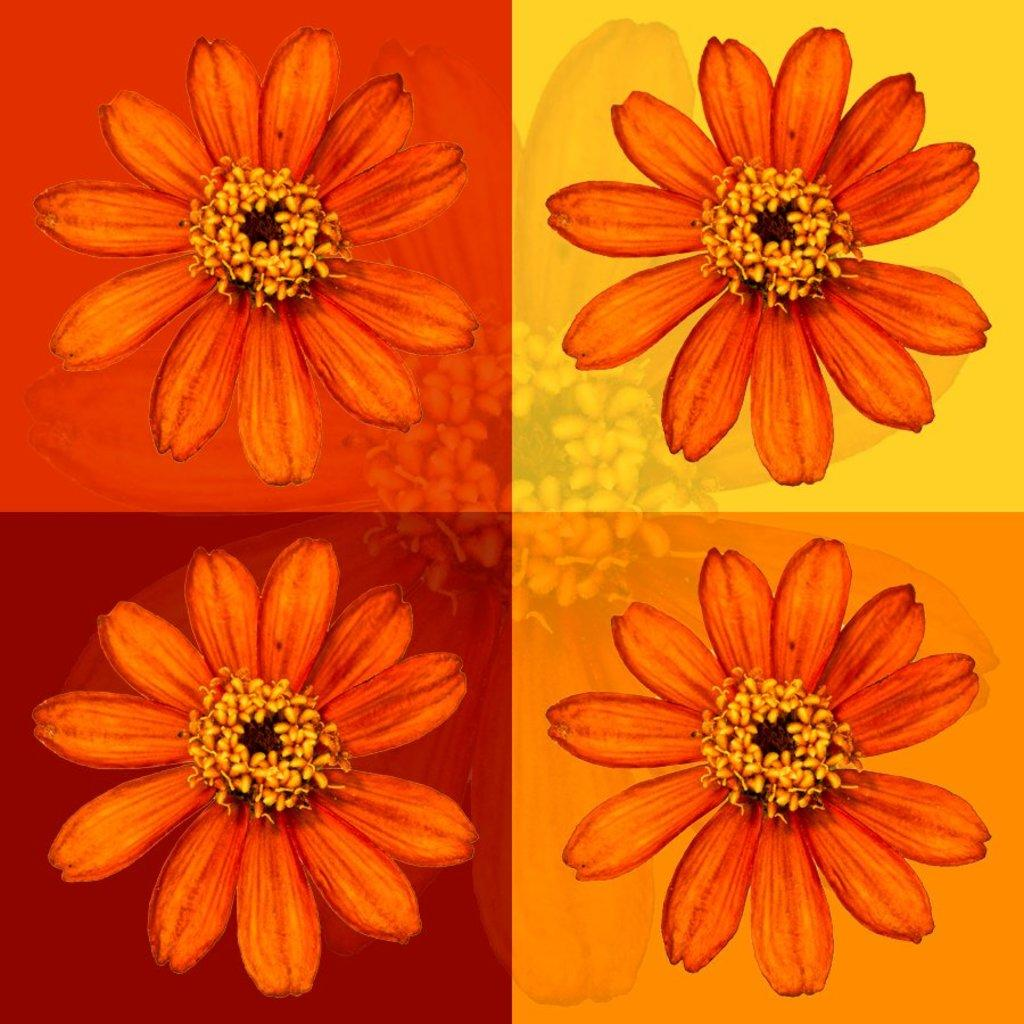What type of artwork is depicted in the image? The image is a collage. What specific elements can be found within the collage? There are flowers in the image. How does the collage increase in size over time in the image? The collage does not increase in size over time in the image; it is a static representation. 